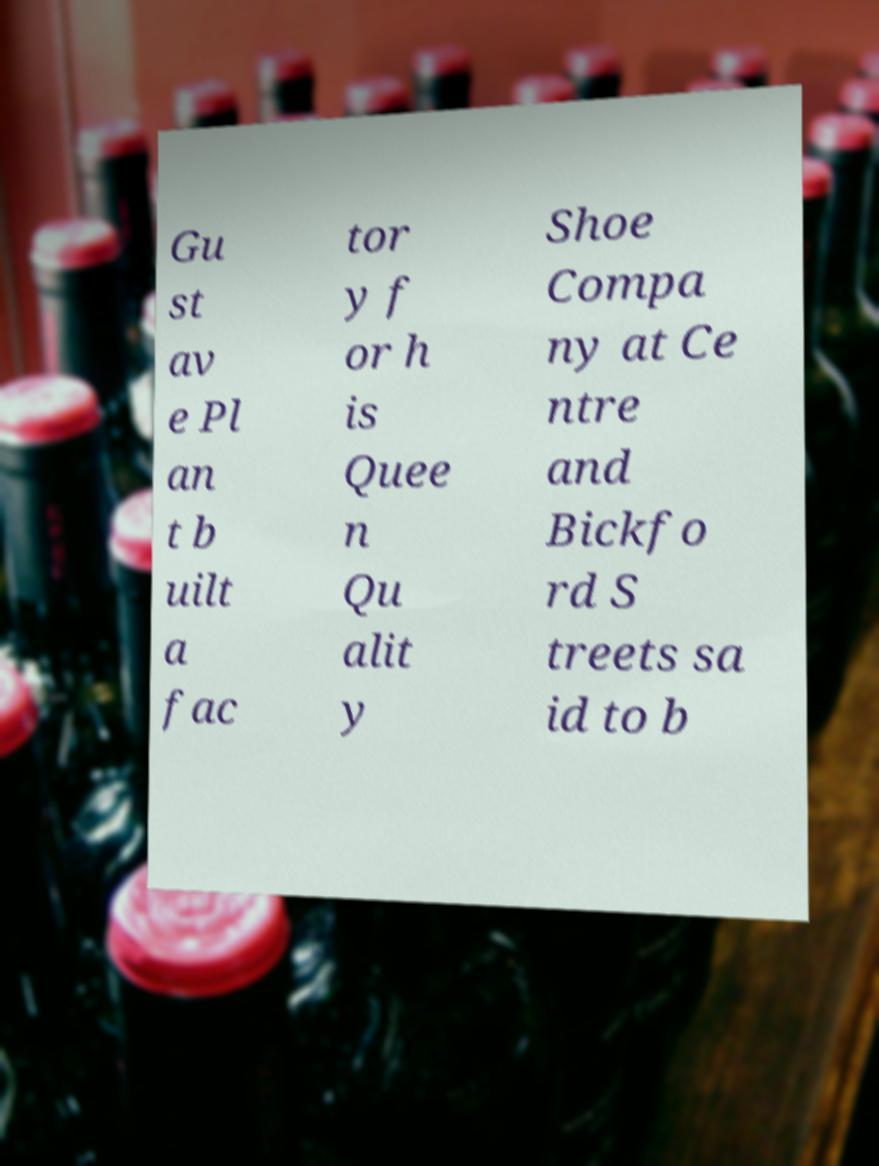Could you extract and type out the text from this image? Gu st av e Pl an t b uilt a fac tor y f or h is Quee n Qu alit y Shoe Compa ny at Ce ntre and Bickfo rd S treets sa id to b 